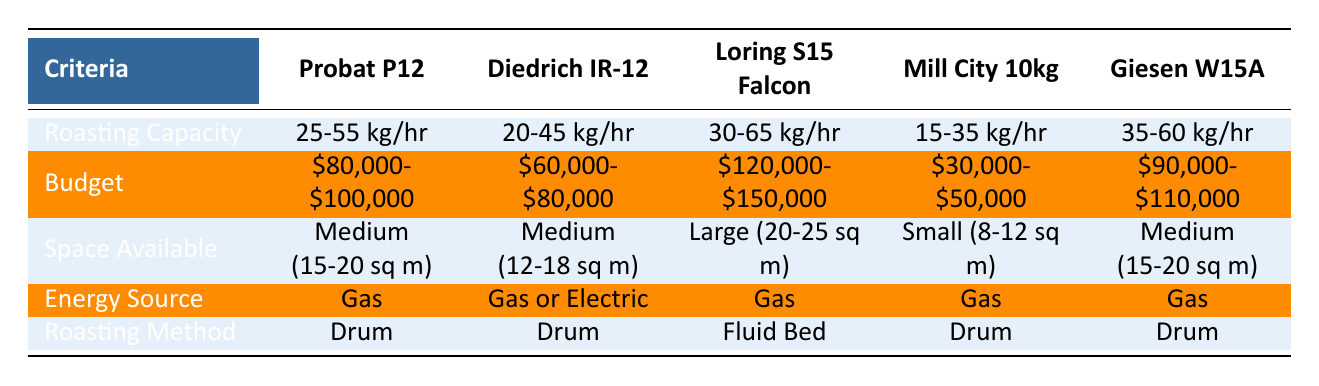What is the roasting capacity of the Diedrich IR-12? The table indicates that the Diedrich IR-12 has a roasting capacity of 20-45 kg/hr.
Answer: 20-45 kg/hr Which roaster has the largest space requirement? According to the table, the Loring S15 Falcon requires the largest space of 20-25 sq m.
Answer: Large (20-25 sq m) Is the Probat P12 the most expensive among the listed roasters? The Probat P12 is priced between $80,000 and $100,000, while the Loring S15 Falcon has a higher budget range of $120,000 to $150,000, making it more expensive.
Answer: No What is the difference in budget between the Mill City 10kg and the Giesen W15A? To find the difference, subtract the upper limit of the Mill City 10kg budget ($50,000) from the lower limit of the Giesen W15A budget ($90,000), which gives $90,000 - $50,000 = $40,000.
Answer: $40,000 How many roasting methods are listed that use gas as an energy source? The table shows that all roasters except for the Diedrich IR-12 list gas as their energy source, making it 4 out of 5 roasters.
Answer: 4 What is the average roasting capacity of all the roasters listed? By taking the midpoint of each capacity range: Probat P12 (40 kg), Diedrich IR-12 (32.5 kg), Loring S15 Falcon (47.5 kg), Mill City 10kg (25 kg), and Giesen W15A (47.5 kg), the average is calculated as (40 + 32.5 + 47.5 + 25 + 47.5) / 5 = 38.5 kg/hr.
Answer: 38.5 kg/hr Do any of the roasters support both gas and electric energy sources? The Diedrich IR-12 supports both gas and electric energy sources, as stated in the table.
Answer: Yes Which roaster has the smallest space requirement and what is that space? The Mill City 10kg has the smallest space requirement of 8-12 sq m according to the table.
Answer: Small (8-12 sq m) What is the budget range for the Giesen W15A? The Giesen W15A is priced between $90,000 and $110,000 as described in the table.
Answer: $90,000-$110,000 